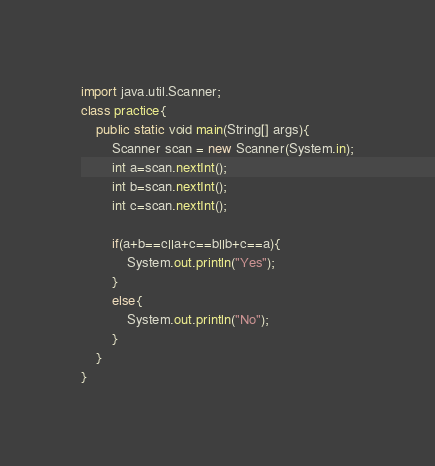<code> <loc_0><loc_0><loc_500><loc_500><_Java_>import java.util.Scanner;
class practice{
    public static void main(String[] args){
        Scanner scan = new Scanner(System.in);
        int a=scan.nextInt();
        int b=scan.nextInt();
        int c=scan.nextInt();
        
        if(a+b==c||a+c==b||b+c==a){
            System.out.println("Yes");
        }
        else{
            System.out.println("No");
        }
    }
}</code> 